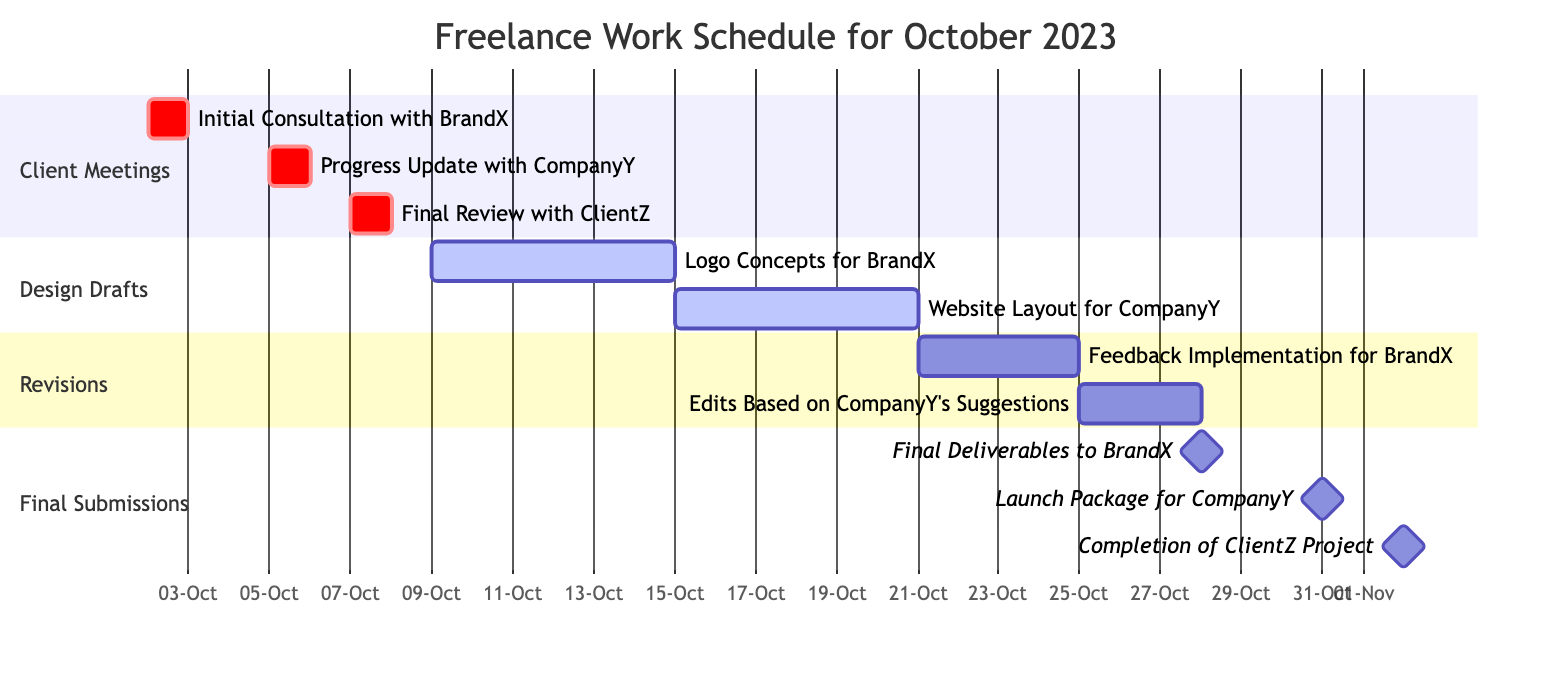What are the dates for the Client Meetings? The Client Meetings task spans from October 2, 2023, to October 8, 2023, which is indicated by the start and end dates shown in the Gantt chart.
Answer: October 2 to October 8 How many tasks are outlined in this Gantt chart? There are four main tasks listed in the Gantt chart: Client Meetings, Design Drafts, Revisions, and Final Submissions. By counting the sections, we arrive at the total number of tasks.
Answer: 4 Which task spans the longest duration? The Design Drafts task has a duration of 1.5 weeks, longer than the other tasks which have either 1 week or less. This can be deduced by comparing the duration of each task.
Answer: Design Drafts On what date is the Final Deliverables to BrandX submission due? The Gantt chart indicates that the Final Deliverables to BrandX is due on October 28, 2023, which is shown as a milestone.
Answer: October 28 What two tasks overlap in their schedule? The Design Drafts and Revisions tasks overlap because Design Drafts ends on October 20 and Revisions begins on October 21, indicating consecutive scheduling. Overlap refers to the timeframes where tasks are planned close to each other.
Answer: Design Drafts and Revisions How many client meetings are scheduled in total? Three client meetings are detailed: Initial Consultation with BrandX, Progress Update with CompanyY, and Final Review with ClientZ. By counting the detailed entries for Client Meetings, we find the total number.
Answer: 3 What is the last task to be completed according to the schedule? The last task listed in the Gantt chart is the Completion of ClientZ Project, which is shown to be due on November 2, 2023. This reflects the sequential nature of deadlines across tasks.
Answer: Completion of ClientZ Project During what period are revisions being implemented based on feedback for BrandX? The revisions for BrandX take place from October 21, 2023, to October 24, 2023, as indicated in the details of the Revisions task. This involves reviewing feedback before finalizing work.
Answer: October 21 to October 24 Which company receives its launch package the earliest in the final submissions phase? The Launch Package for CompanyY is scheduled for October 31, while the Final Deliverables for BrandX are due on October 28, making BrandX the earliest receiving party for final submissions.
Answer: BrandX 